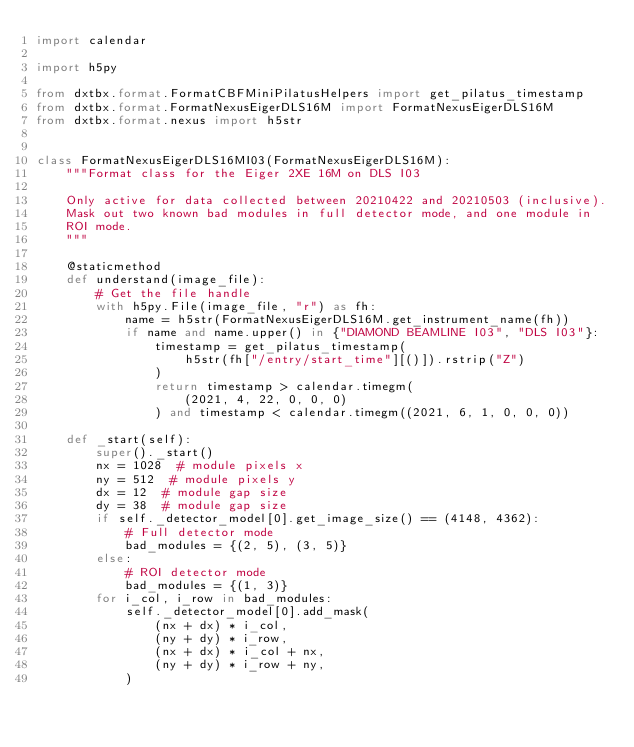<code> <loc_0><loc_0><loc_500><loc_500><_Python_>import calendar

import h5py

from dxtbx.format.FormatCBFMiniPilatusHelpers import get_pilatus_timestamp
from dxtbx.format.FormatNexusEigerDLS16M import FormatNexusEigerDLS16M
from dxtbx.format.nexus import h5str


class FormatNexusEigerDLS16MI03(FormatNexusEigerDLS16M):
    """Format class for the Eiger 2XE 16M on DLS I03

    Only active for data collected between 20210422 and 20210503 (inclusive).
    Mask out two known bad modules in full detector mode, and one module in
    ROI mode.
    """

    @staticmethod
    def understand(image_file):
        # Get the file handle
        with h5py.File(image_file, "r") as fh:
            name = h5str(FormatNexusEigerDLS16M.get_instrument_name(fh))
            if name and name.upper() in {"DIAMOND BEAMLINE I03", "DLS I03"}:
                timestamp = get_pilatus_timestamp(
                    h5str(fh["/entry/start_time"][()]).rstrip("Z")
                )
                return timestamp > calendar.timegm(
                    (2021, 4, 22, 0, 0, 0)
                ) and timestamp < calendar.timegm((2021, 6, 1, 0, 0, 0))

    def _start(self):
        super()._start()
        nx = 1028  # module pixels x
        ny = 512  # module pixels y
        dx = 12  # module gap size
        dy = 38  # module gap size
        if self._detector_model[0].get_image_size() == (4148, 4362):
            # Full detector mode
            bad_modules = {(2, 5), (3, 5)}
        else:
            # ROI detector mode
            bad_modules = {(1, 3)}
        for i_col, i_row in bad_modules:
            self._detector_model[0].add_mask(
                (nx + dx) * i_col,
                (ny + dy) * i_row,
                (nx + dx) * i_col + nx,
                (ny + dy) * i_row + ny,
            )
</code> 